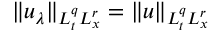<formula> <loc_0><loc_0><loc_500><loc_500>\| u _ { \lambda } \| _ { L _ { t } ^ { q } L _ { x } ^ { r } } = \| u \| _ { L _ { t } ^ { q } L _ { x } ^ { r } }</formula> 